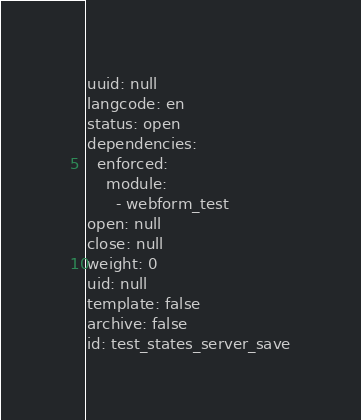<code> <loc_0><loc_0><loc_500><loc_500><_YAML_>uuid: null
langcode: en
status: open
dependencies:
  enforced:
    module:
      - webform_test
open: null
close: null
weight: 0
uid: null
template: false
archive: false
id: test_states_server_save</code> 